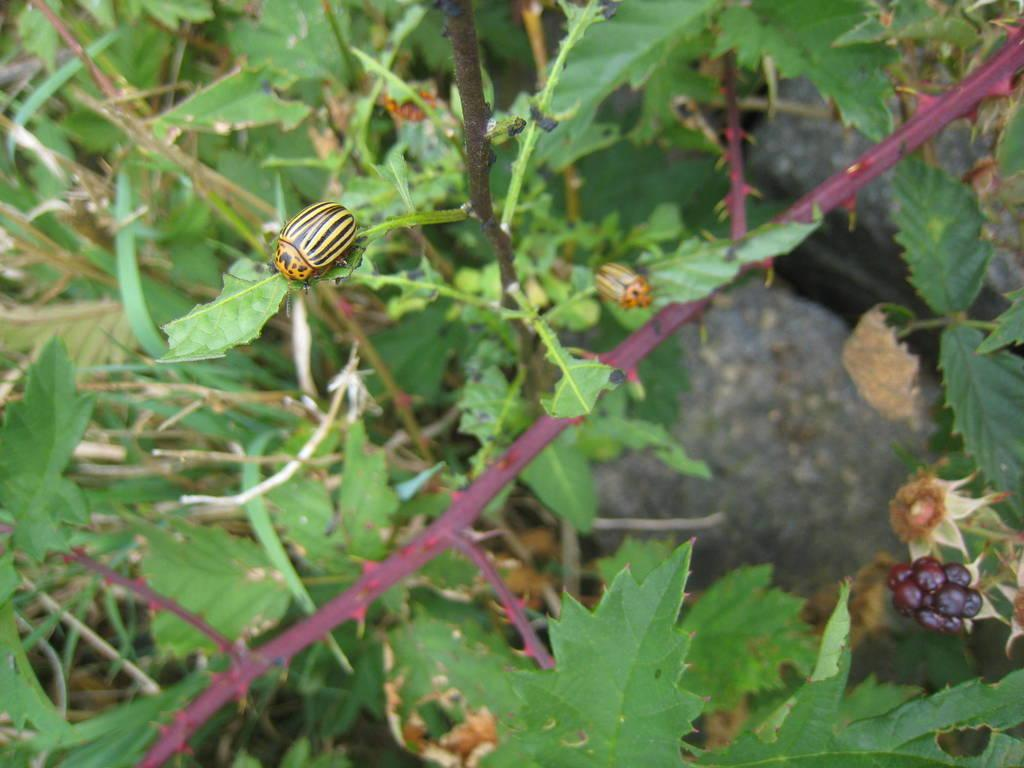How many bugs are present in the image? There are 2 bugs in the image. Where are the bugs located? The bugs are on a plant. What library is the flame located in the image? There is no library or flame present in the image; it features 2 bugs on a plant. 